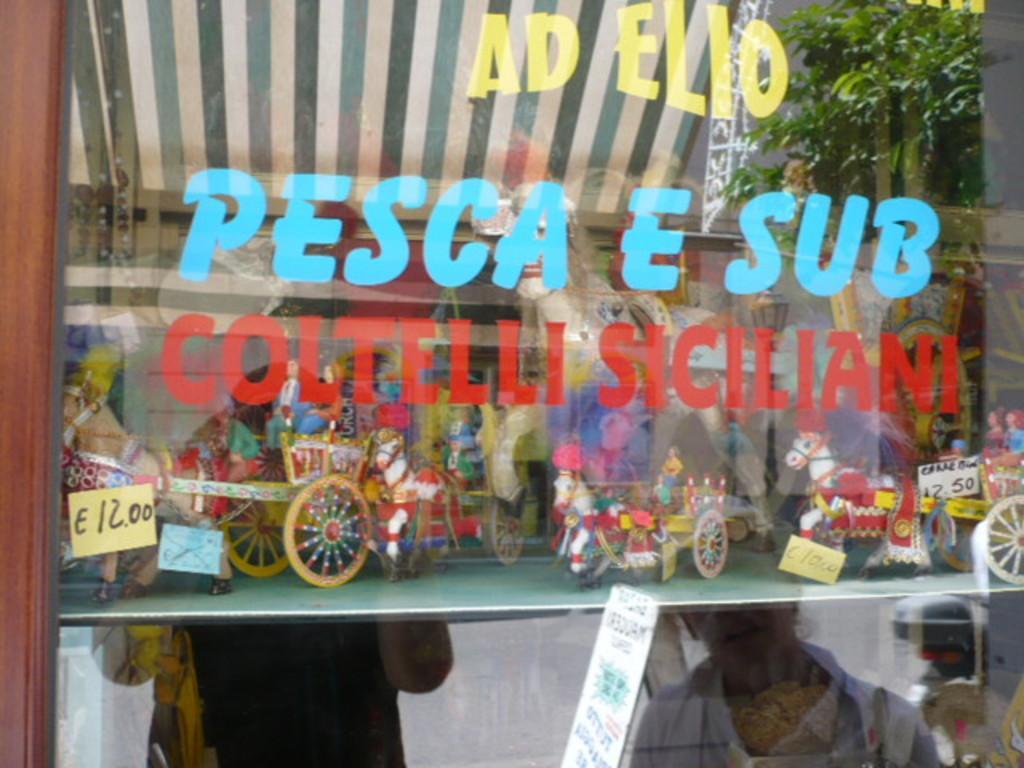In one or two sentences, can you explain what this image depicts? In the picture there is a glass in front of a store and the pictures of two people were being reflected on the glass of the store. 